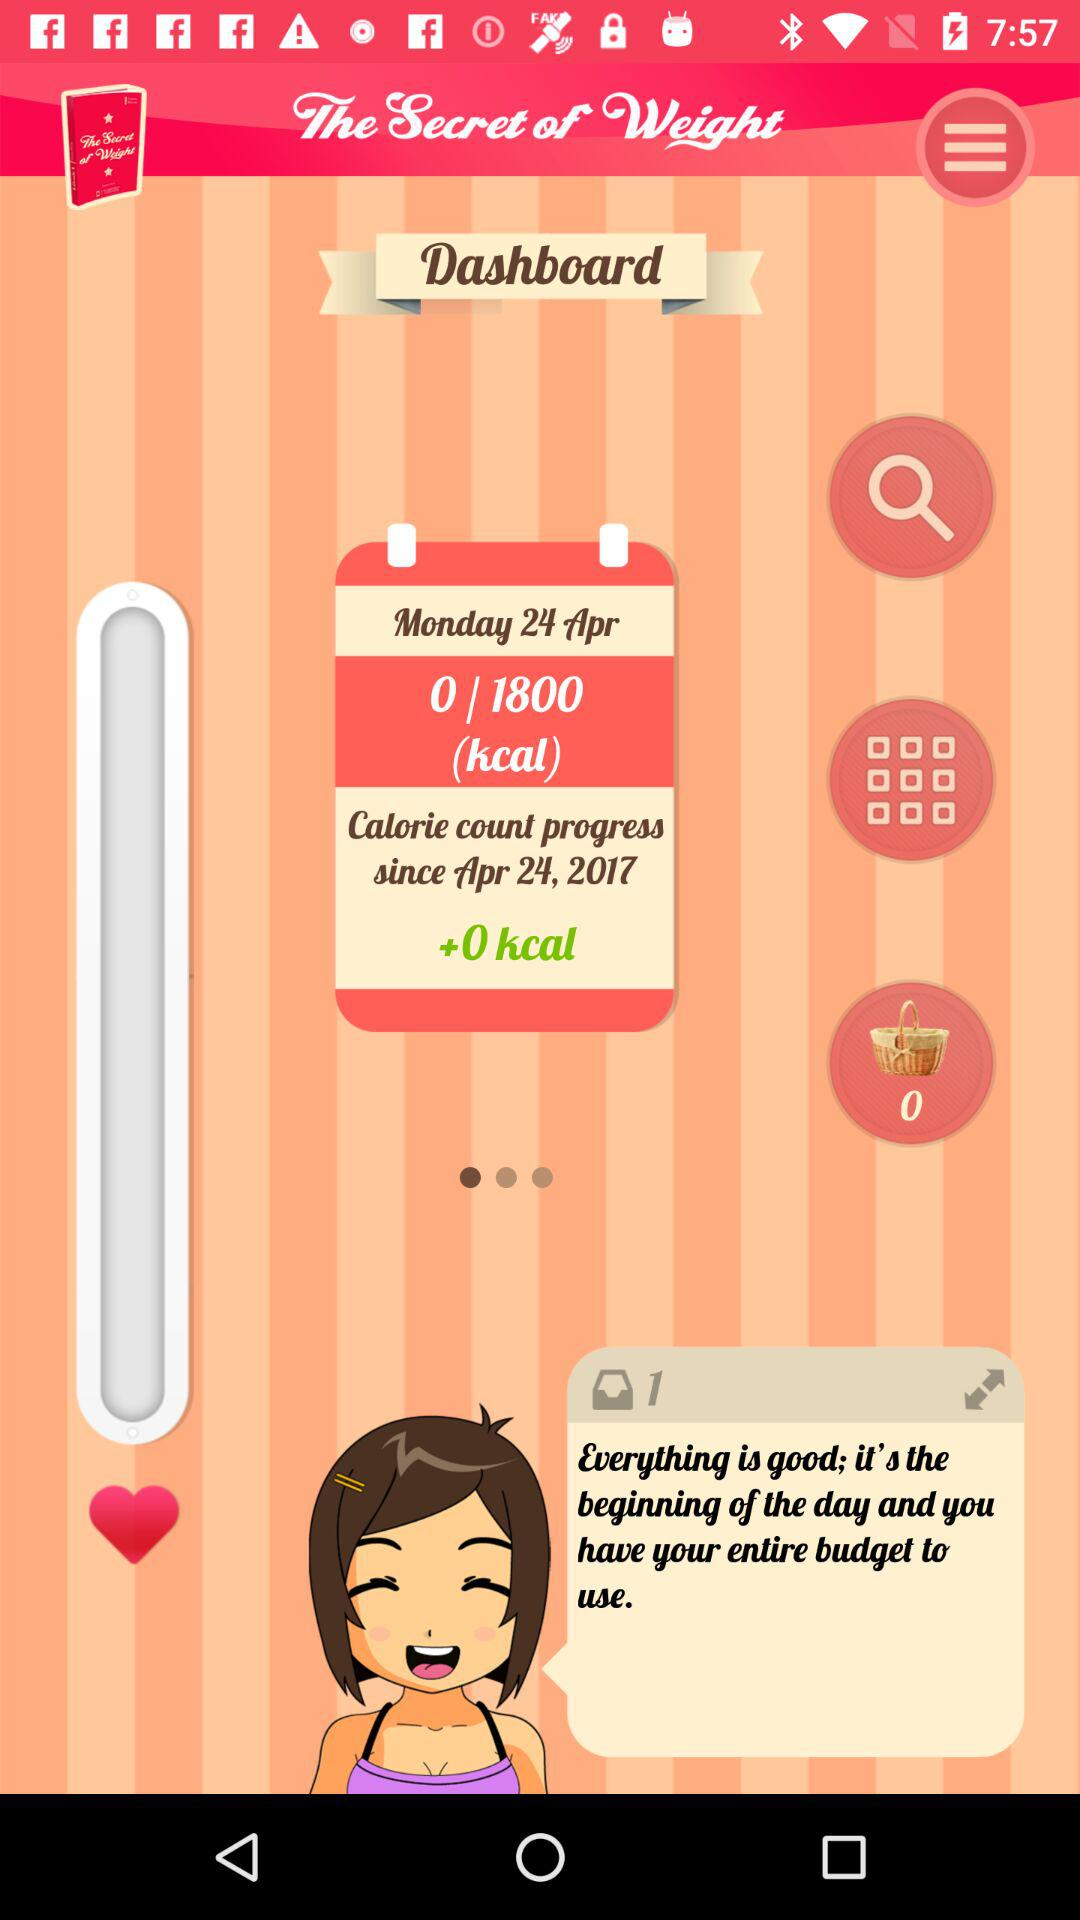How many calories have been counted since April 24, 2017? The calorie count progress is 0/1800 calories since April 24, 2017. 